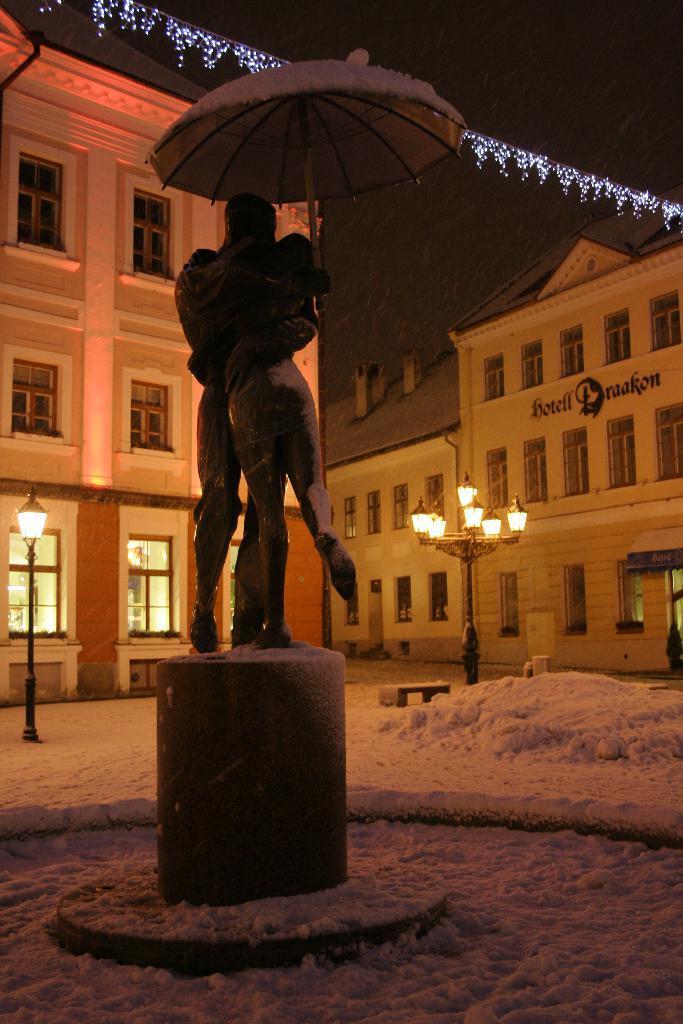Could you give a brief overview of what you see in this image? In the center of the image there is a statue. In the background there are buildings, snow, lights and sky. 